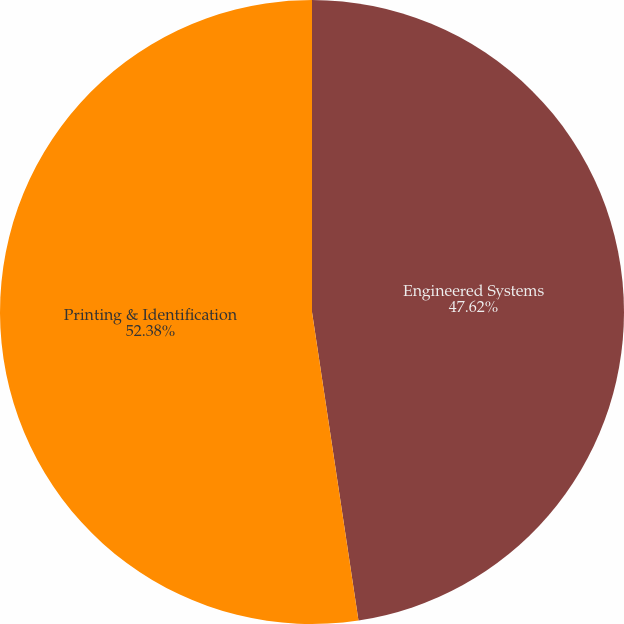Convert chart. <chart><loc_0><loc_0><loc_500><loc_500><pie_chart><fcel>Engineered Systems<fcel>Printing & Identification<nl><fcel>47.62%<fcel>52.38%<nl></chart> 